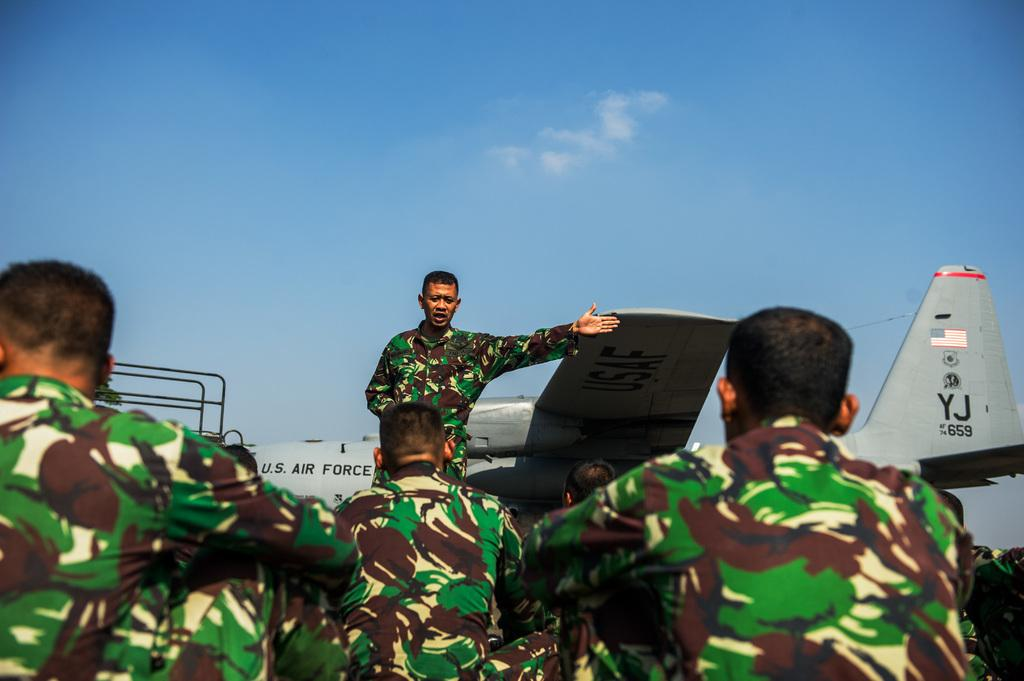How many people are in the image? There is a group of people in the image. Can you describe the position of the man in the image? There is a man standing in front of the group. What else can be seen in the image besides the people? There is an airplane and rods visible in the image. What is visible in the background of the image? The sky is visible in the background of the image. Is the group of people playing a game in the image? There is no indication in the image that the group of people is playing a game. What type of adjustment is being made to the rods in the image? There is no adjustment being made to the rods in the image; they are stationary. 